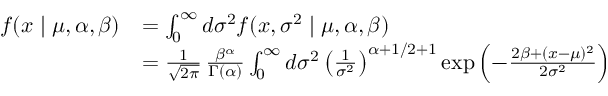Convert formula to latex. <formula><loc_0><loc_0><loc_500><loc_500>{ \begin{array} { r l } { f ( x | \mu , \alpha , \beta ) } & { = \int _ { 0 } ^ { \infty } d \sigma ^ { 2 } f ( x , \sigma ^ { 2 } | \mu , \alpha , \beta ) } \\ & { = { \frac { 1 } { \sqrt { 2 \pi } } } \, { \frac { \beta ^ { \alpha } } { \Gamma ( \alpha ) } } \int _ { 0 } ^ { \infty } d \sigma ^ { 2 } \left ( { \frac { 1 } { \sigma ^ { 2 } } } \right ) ^ { \alpha + 1 / 2 + 1 } \exp \left ( - { \frac { 2 \beta + ( x - \mu ) ^ { 2 } } { 2 \sigma ^ { 2 } } } \right ) } \end{array} }</formula> 